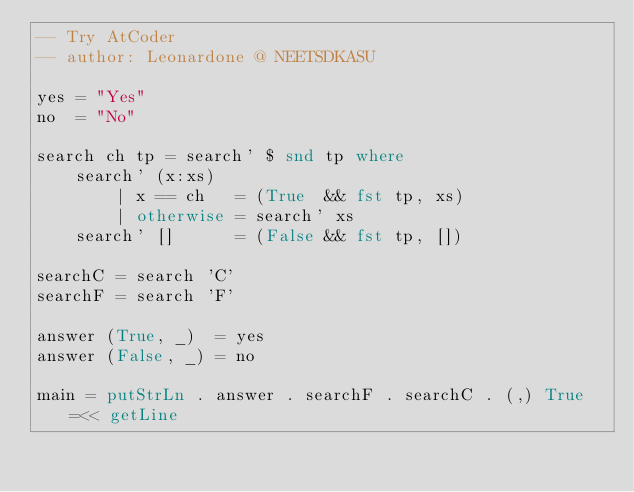<code> <loc_0><loc_0><loc_500><loc_500><_Haskell_>-- Try AtCoder
-- author: Leonardone @ NEETSDKASU

yes = "Yes"
no  = "No"

search ch tp = search' $ snd tp where
    search' (x:xs)
        | x == ch   = (True  && fst tp, xs)
        | otherwise = search' xs
    search' []      = (False && fst tp, [])

searchC = search 'C'
searchF = search 'F'

answer (True, _)  = yes
answer (False, _) = no

main = putStrLn . answer . searchF . searchC . (,) True =<< getLine

</code> 